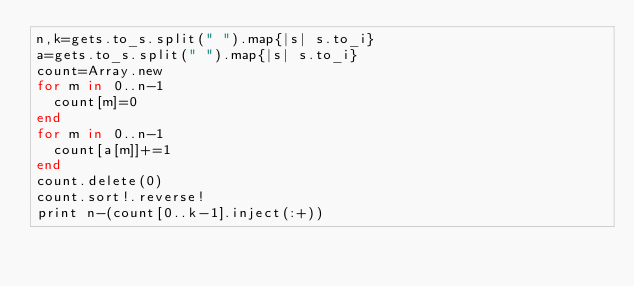<code> <loc_0><loc_0><loc_500><loc_500><_Ruby_>n,k=gets.to_s.split(" ").map{|s| s.to_i}
a=gets.to_s.split(" ").map{|s| s.to_i}
count=Array.new
for m in 0..n-1
  count[m]=0
end
for m in 0..n-1
  count[a[m]]+=1
end
count.delete(0)
count.sort!.reverse!
print n-(count[0..k-1].inject(:+))</code> 